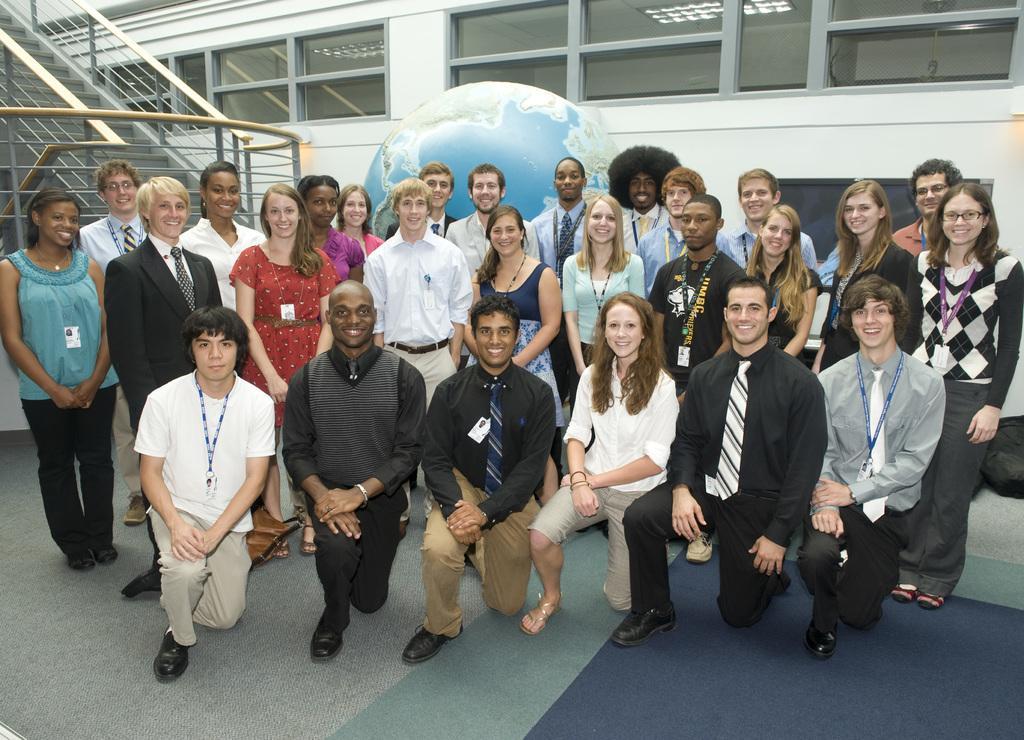Please provide a concise description of this image. In this image, we can see a group of people are smiling. Few are standing and knee down on the floor. Background we can see a wall, glass windows, railings and stairs. 